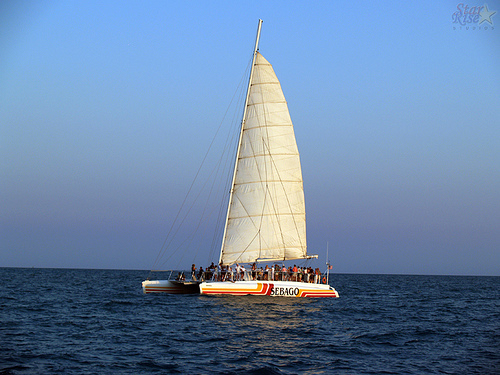<image>
Is the sail above the water? Yes. The sail is positioned above the water in the vertical space, higher up in the scene. Where is the boat in relation to the sea? Is it on the sea? Yes. Looking at the image, I can see the boat is positioned on top of the sea, with the sea providing support. Is the sail on the people? No. The sail is not positioned on the people. They may be near each other, but the sail is not supported by or resting on top of the people. Is there a church in front of the boat? No. The church is not in front of the boat. The spatial positioning shows a different relationship between these objects. 